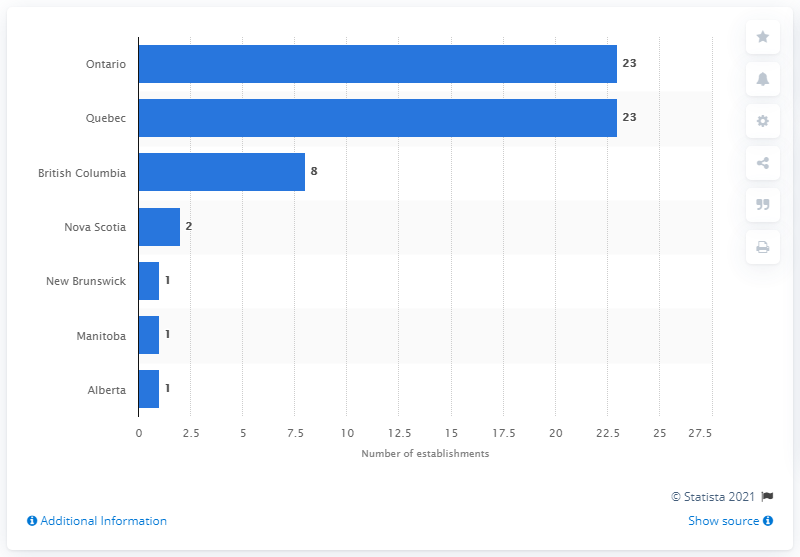List a handful of essential elements in this visual. As of December 2020, there were 23 footwear manufacturing establishments in Quebec. As of December 2020, there were a total of 23 footwear manufacturing establishments in the province of Ontario. As of December 2020, the sum of footwear manufacturing establishments in Nova Scotia and Manitoba is 3. 